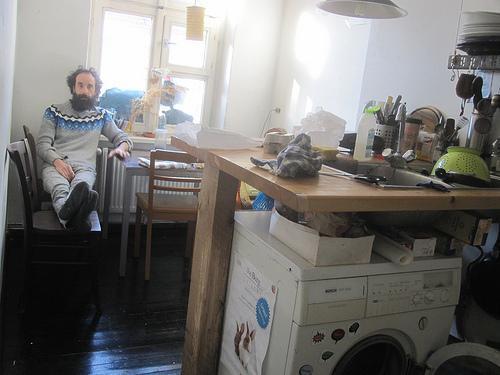How many people are in the picture?
Give a very brief answer. 1. 